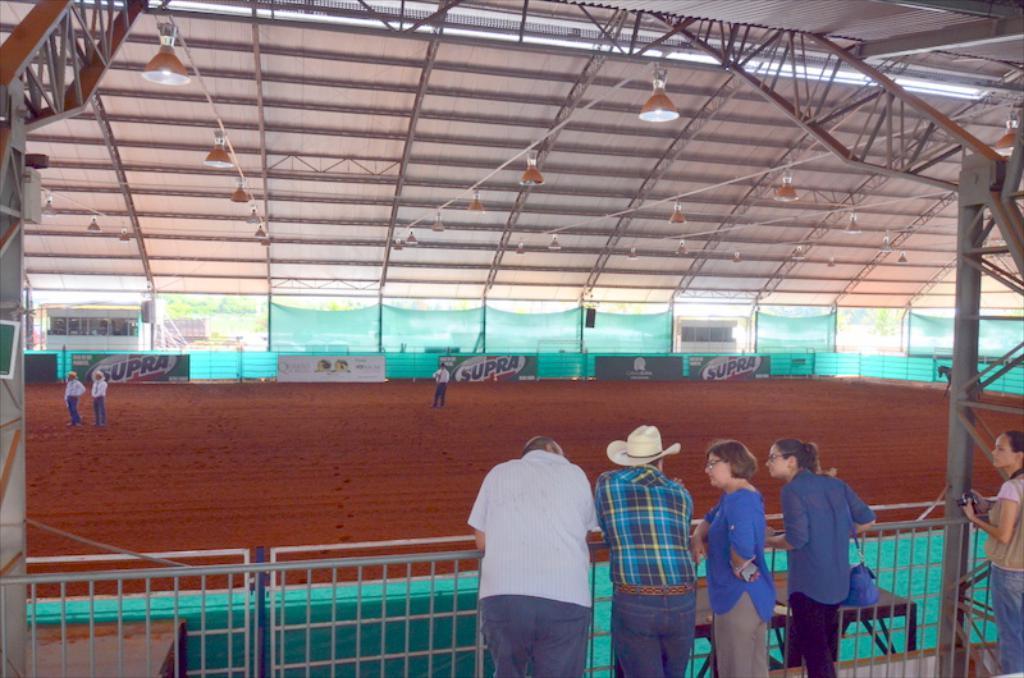Describe this image in one or two sentences. In this image there are a few people standing in front of the railing and there are a few other people standing on the surface of the sand, around them there is a cloth with sky blue color like a fencing wall and there are banners with some text and in the background there are trees. At the top of the image there is a ceiling with lights. 